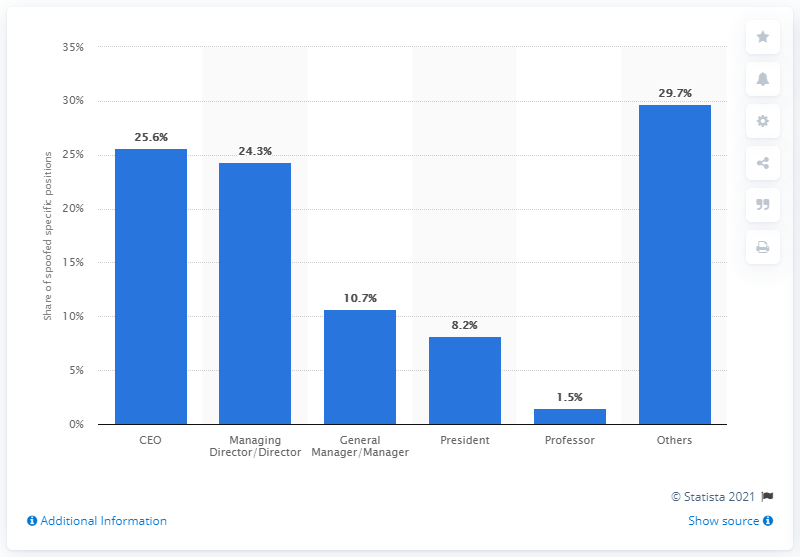What percentage of BEC scammers pretend to be CEOs of their victim companies? According to the data displayed in the image, 25.6% of BEC (Business Email Compromise) scammers pretend to be CEOs of their target companies. This information, extracted from a bar chart, highlights that CEOs are impersonated second most often by BEC attackers, following the 'Others' category, which accounts for 29.7%. 